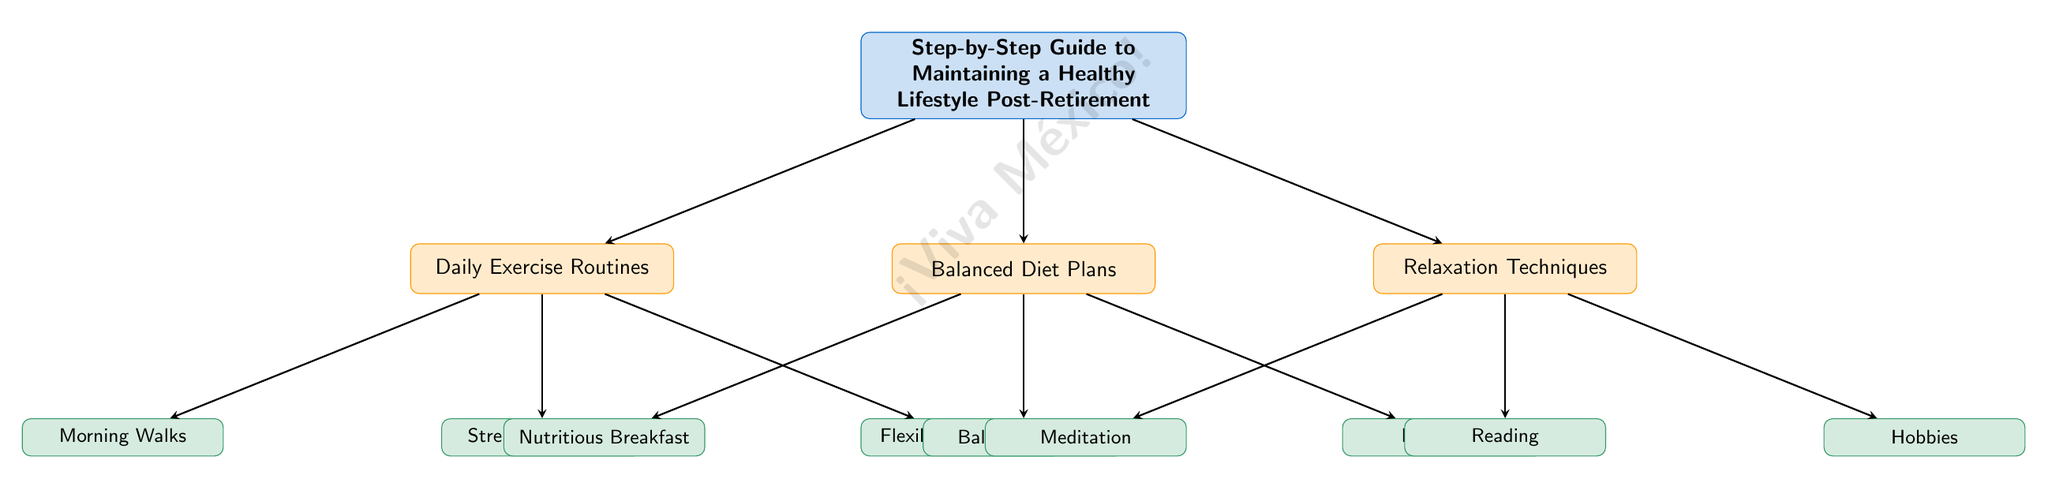What are the three main categories of maintaining a healthy lifestyle post-retirement? The diagram lists three categories under the main header 'Step-by-Step Guide to Maintaining a Healthy Lifestyle Post-Retirement': Daily Exercise Routines, Balanced Diet Plans, and Relaxation Techniques.
Answer: Daily Exercise Routines, Balanced Diet Plans, Relaxation Techniques How many sub-nodes are attached to the Daily Exercise Routines category? There are three sub-nodes connected to the Daily Exercise Routines node: Morning Walks, Strength Training, and Flexibility Exercises. Therefore, the count is three.
Answer: 3 Which sub-node relates to drinking fluids? The sub-node related to drinking fluids is Hydration, which falls under the Balanced Diet Plans category.
Answer: Hydration What is the main activity listed under the Relaxation Techniques category? The three activities under Relaxation Techniques include Meditation, Reading, and Hobbies. Since the question asks for a main activity, the first in the list is Meditation.
Answer: Meditation How are the Daily Exercise Routines and Balanced Diet Plans categories related to the main topic? Both categories are directly connected to the main topic 'Step-by-Step Guide to Maintaining a Healthy Lifestyle Post-Retirement' by arrows, indicating that they are essential components of achieving a healthy lifestyle post-retirement.
Answer: They are directly connected to the main topic Which two exercise activities focus on physical conditioning? The two activities that focus on physical conditioning are Strength Training and Flexibility Exercises. Morning Walks is also aerobic but not strictly conditioning.
Answer: Strength Training, Flexibility Exercises What does the watermark in the diagram say? The watermark in the diagram is a light and large text that reads '¡Viva México!' placed diagonally across the central area of the diagram.
Answer: ¡Viva México! 